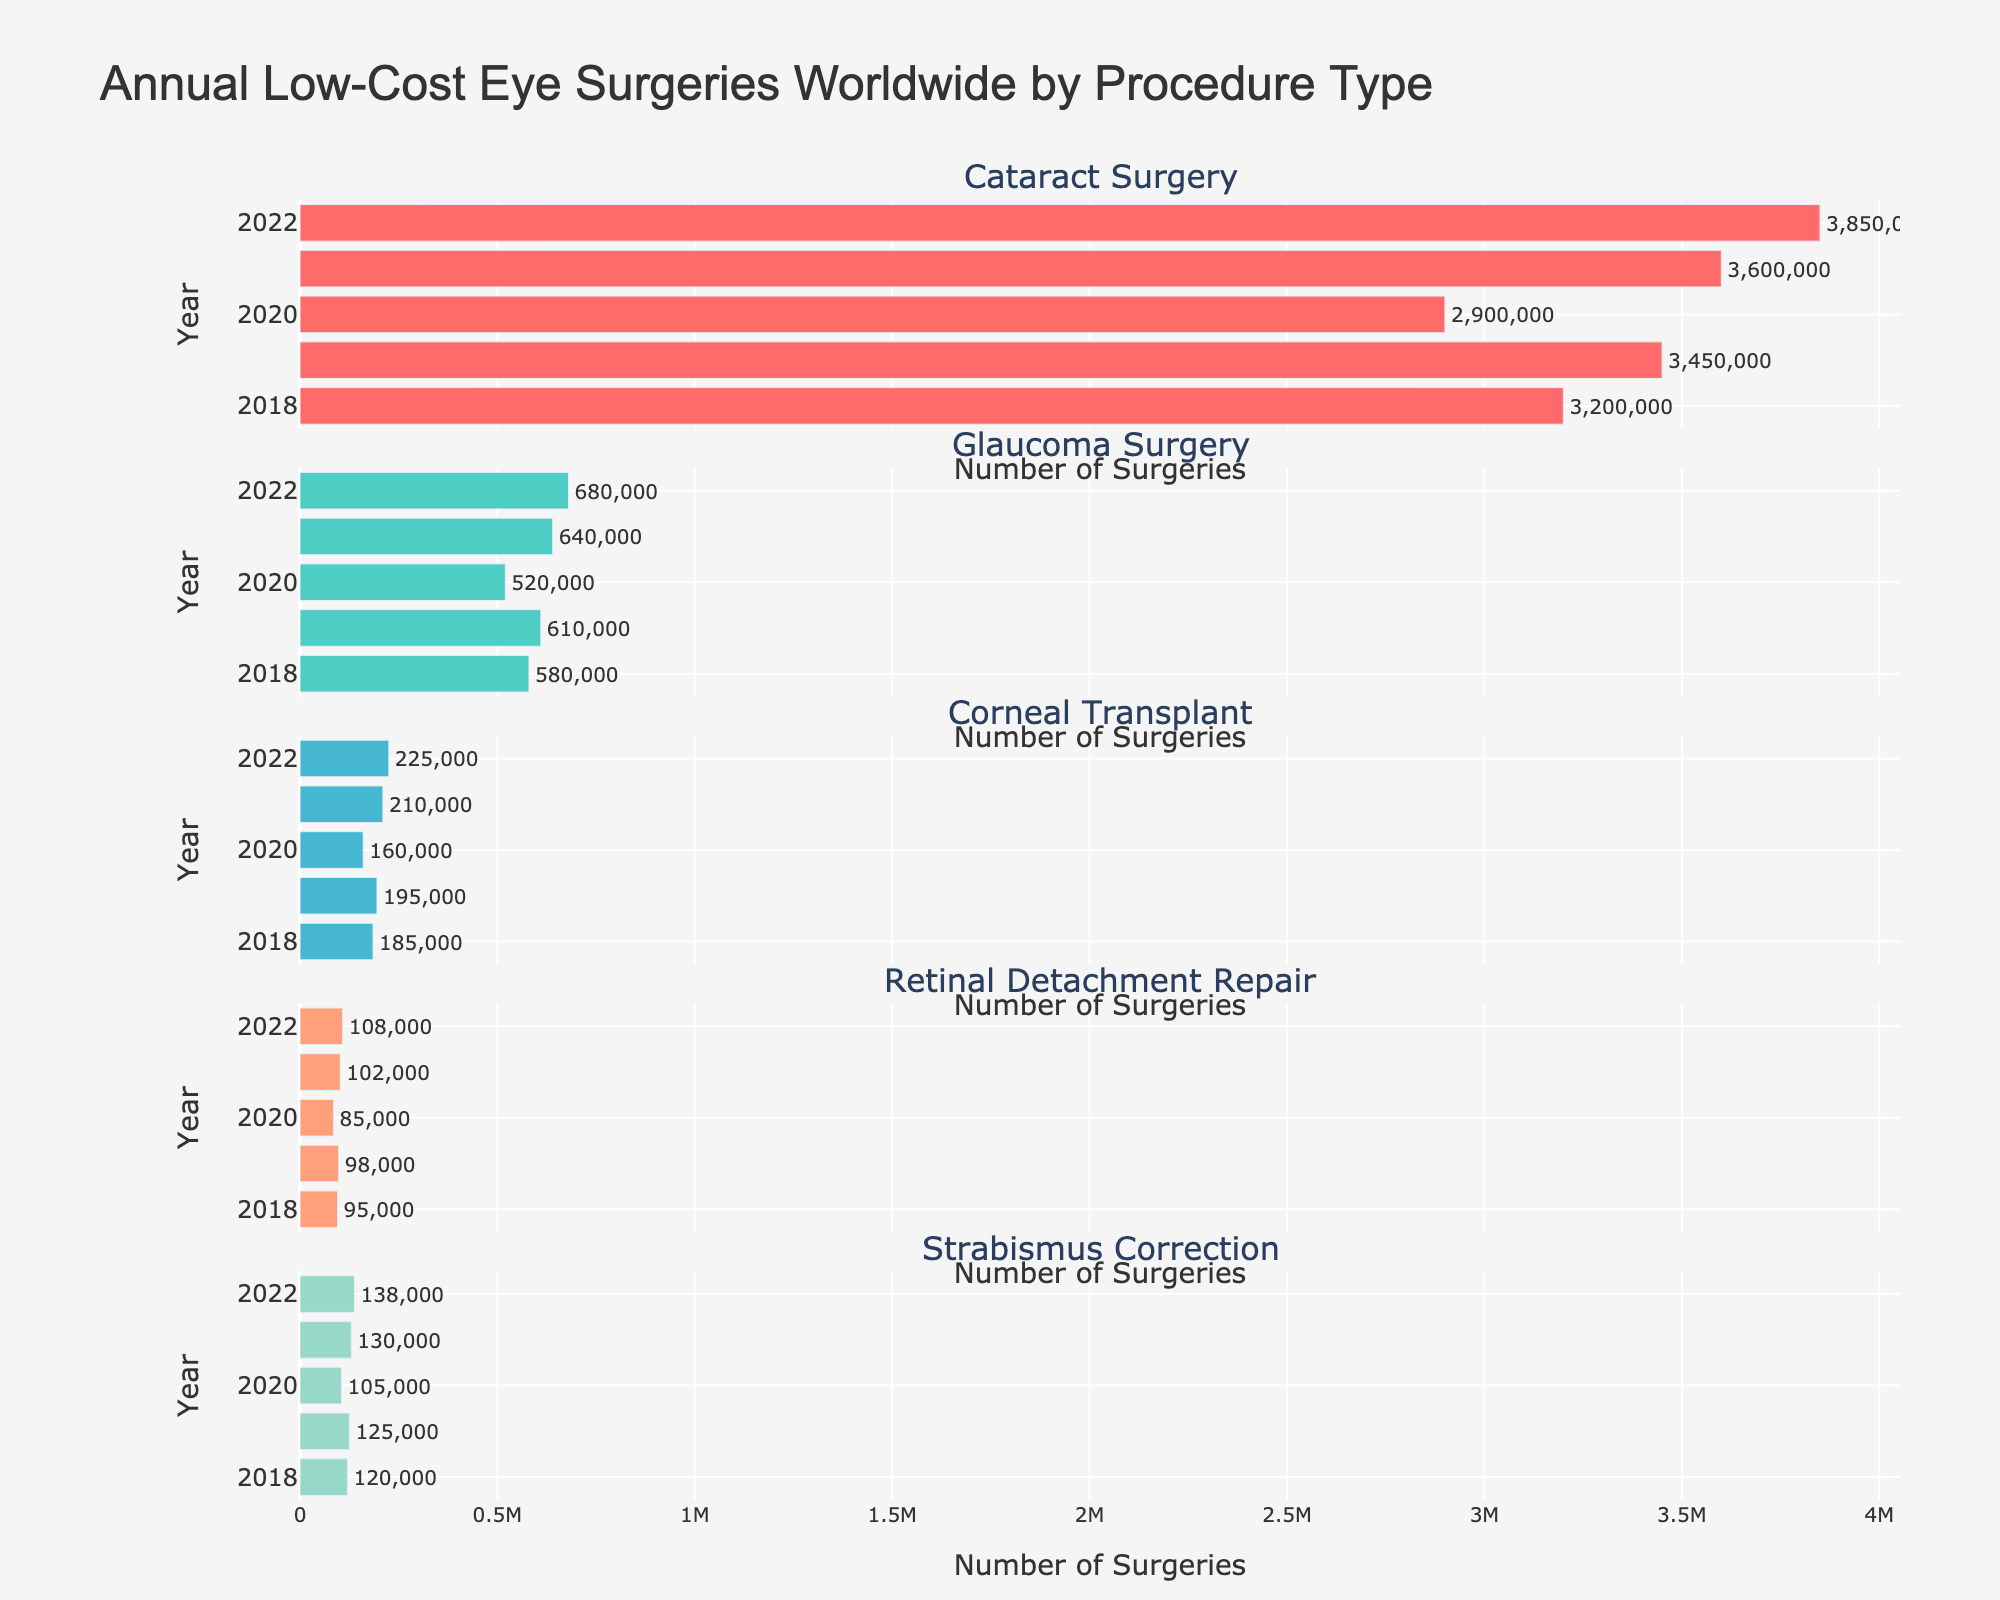How many subplots are in the figure? The figure has three subplots, each representing one of the operating systems: Android, iOS, and Other.
Answer: 3 Which operating system had the highest sales in 2021? By examining the bars in the 2021 row across all subplots, Android has the longest bar, indicating the highest sales.
Answer: Android What is the title of the figure? The title of the figure is located at the top of the plot and states "Global Smartphone Sales by Operating System".
Answer: Global Smartphone Sales by Operating System How did the sales of the "Other" operating systems change from 2018 to 2022? The "Other" subplot shows bars decreasing in length from 2018 (3.2) to 2022 (1.1), indicating that sales decreased.
Answer: Decreased Which year had the lowest iOS sales, and what were the sales figures? The shortest bar in the iOS subplot corresponds to the year 2020 with sales of 199.8 million.
Answer: 2020, 199.8 Compare the Android sales figures in 2019 with those in 2020. By comparing the lengths of the bars in the Android subplot for the years 2019 and 2020, sales in 2019 are 1243.5 million, and sales in 2020 are 1152.8 million. Sales dropped by 90.7 million.
Answer: 2019 was higher by 90.7 million What is the overall trend of Android sales from 2018 to 2022? Observing the Android subplot, sales figures start high in 2018, decrease in 2019 and 2020, increase in 2021, and then decrease again in 2022.
Answer: Fluctuating Which operating system saw an increase in sales in 2021 compared to 2020? By comparing the bar lengths for 2020 and 2021 in each subplot, both Android and iOS show an increase in 2021.
Answer: Android and iOS In which year did the combined sales of all three operating systems peak? Summing up the sales figures for each year across all subplots shows the highest combined sales occurred in 2021.
Answer: 2021 